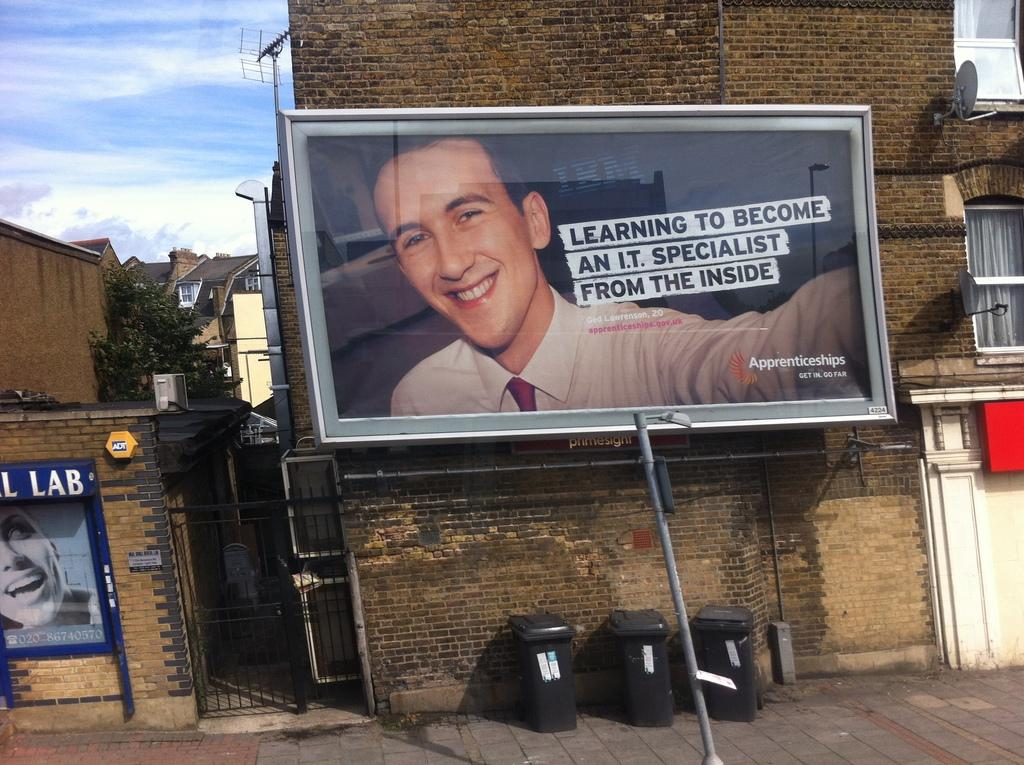Provide a one-sentence caption for the provided image. A billboard advertising how to become an i.t. specialist. 